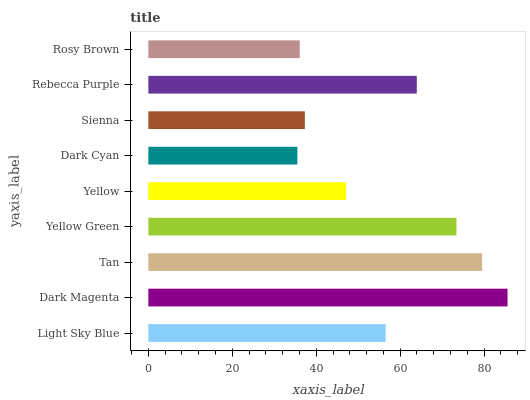Is Dark Cyan the minimum?
Answer yes or no. Yes. Is Dark Magenta the maximum?
Answer yes or no. Yes. Is Tan the minimum?
Answer yes or no. No. Is Tan the maximum?
Answer yes or no. No. Is Dark Magenta greater than Tan?
Answer yes or no. Yes. Is Tan less than Dark Magenta?
Answer yes or no. Yes. Is Tan greater than Dark Magenta?
Answer yes or no. No. Is Dark Magenta less than Tan?
Answer yes or no. No. Is Light Sky Blue the high median?
Answer yes or no. Yes. Is Light Sky Blue the low median?
Answer yes or no. Yes. Is Yellow Green the high median?
Answer yes or no. No. Is Dark Magenta the low median?
Answer yes or no. No. 